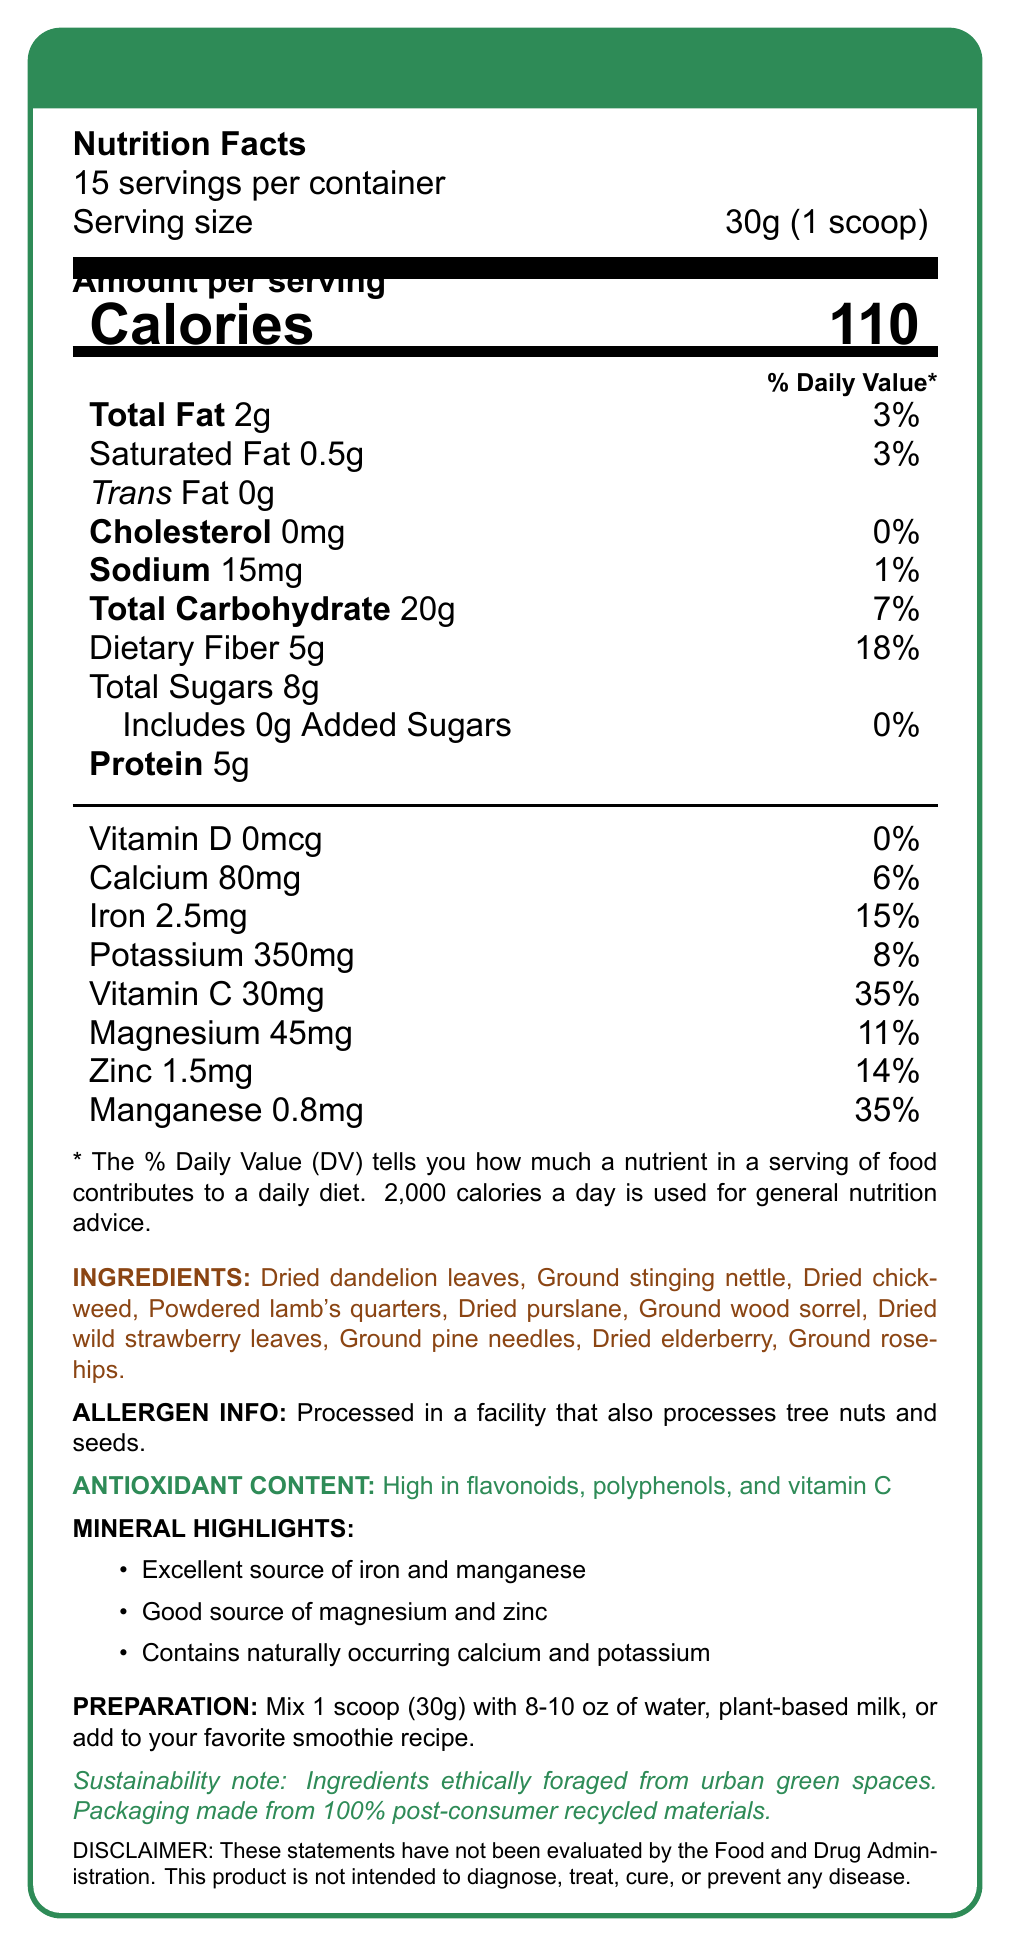What is the serving size of the Urban Wildling Smoothie Mix? The serving size is specified at the top of the Nutrition Facts section: "Serving size 30g (1 scoop)."
Answer: 30g (1 scoop) How many servings are there per container? According to the Nutrition Facts section, "15 servings per container" is listed at the top.
Answer: 15 servings What percentage of the daily value of iron does one serving provide? The Nutrition Facts panel shows that one serving provides 2.5mg of iron, which corresponds to 15% of the daily value.
Answer: 15% How much dietary fiber is in one serving? The amount of dietary fiber per serving is stated in the Total Carbohydrate section of the Nutrition Facts: "Dietary Fiber 5g."
Answer: 5g Which minerals are highlighted as excellent sources in the Urban Wildling Smoothie Mix? The Mineral Highlights section mentions: "Excellent source of iron and manganese."
Answer: Iron and manganese How many calories are in one serving of Urban Wildling Smoothie Mix? The number of calories per serving is prominently displayed at the top of the Nutrition Facts as "Calories 110."
Answer: 110 Which of the following is NOT an ingredient in the Urban Wildling Smoothie Mix?
A. Ground stinging nettle
B. Dried alderberry
C. Ground rosehips The ingredients list mentions "Dried elderberry," not "Dried alderberry."
Answer: B. Dried alderberry What is the percentage daily value of calcium provided by one serving? The Nutrition Facts section lists calcium at 80mg which is 6% of the daily value.
Answer: 6% Is the product processed in a facility that also processes tree nuts and seeds? The Allergen Info section specifies: "Processed in a facility that also processes tree nuts and seeds."
Answer: Yes Which vitamins and minerals have the highest daily value percentage per serving in the Urban Wildling Smoothie Mix? 
A. Calcium and Iron
B. Vitamin C and Manganese
C. Sodium and Zinc
D. Potassium and Magnesium The Nutrition Facts show Vitamin C at 35% and Manganese also at 35%, which are the highest percentages listed.
Answer: B. Vitamin C and Manganese Does the Urban Wildling Smoothie Mix contain any added sugars? The Nutrition Facts declare "Includes 0g Added Sugars" under the Total Sugars section.
Answer: No Summarize the main features and benefits of the Urban Wildling Smoothie Mix. The document outlines the nutritional composition, ingredients, allergen information, antioxidant content, mineral highlights, preparation instructions, and sustainability note of the Urban Wildling Smoothie Mix.
Answer: The Urban Wildling Smoothie Mix offers a blend of wild edible plants and is high in antioxidants such as flavonoids, polyphenols, and vitamin C. It boasts significant mineral content, including iron, manganese, magnesium, zinc, calcium, and potassium. Each serving provides 110 calories, 5g dietary fiber, and 5g protein. This mix is ethically sourced, processed in a facility that handles tree nuts and seeds, and suggests mixing with water or plant-based milk. The packaging is environmentally friendly. What is the sodium content in one serving of the Urban Wildling Smoothie Mix? The Nutrition Facts state that each serving contains 15mg of sodium.
Answer: 15mg Can I find the exact sourcing locations of the ingredients in the Urban Wildling Smoothie Mix from the given document? The document mentions that ingredients are ethically foraged from urban green spaces but does not specify the exact locations.
Answer: Cannot be determined 